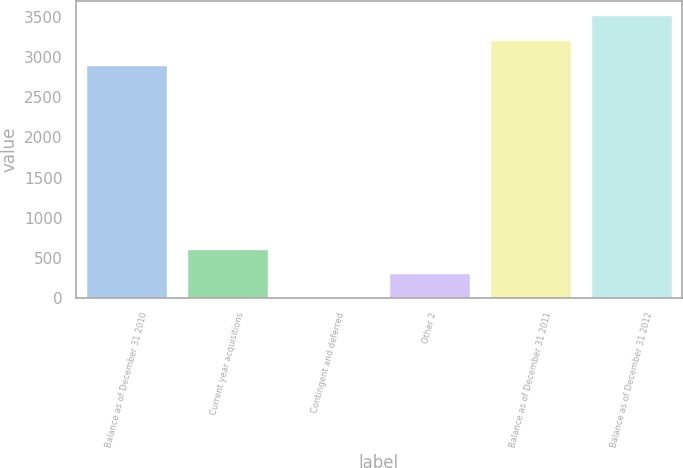<chart> <loc_0><loc_0><loc_500><loc_500><bar_chart><fcel>Balance as of December 31 2010<fcel>Current year acquisitions<fcel>Contingent and deferred<fcel>Other 2<fcel>Balance as of December 31 2011<fcel>Balance as of December 31 2012<nl><fcel>2906<fcel>615.56<fcel>0.8<fcel>308.18<fcel>3213.38<fcel>3520.76<nl></chart> 